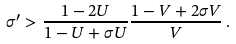Convert formula to latex. <formula><loc_0><loc_0><loc_500><loc_500>\sigma ^ { \prime } > \frac { 1 - 2 U } { 1 - U + \sigma U } \frac { 1 - V + 2 \sigma V } { V } \, .</formula> 